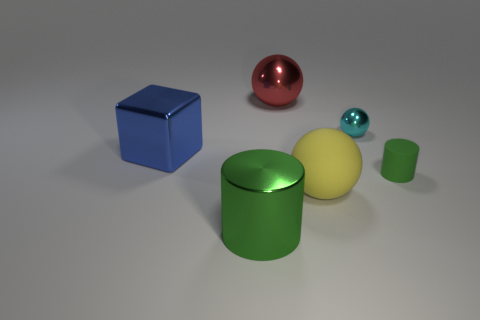Add 3 small cylinders. How many objects exist? 9 Subtract all cubes. How many objects are left? 5 Subtract 0 red blocks. How many objects are left? 6 Subtract all large rubber objects. Subtract all large green metal cubes. How many objects are left? 5 Add 3 blue metallic objects. How many blue metallic objects are left? 4 Add 3 tiny yellow metallic cubes. How many tiny yellow metallic cubes exist? 3 